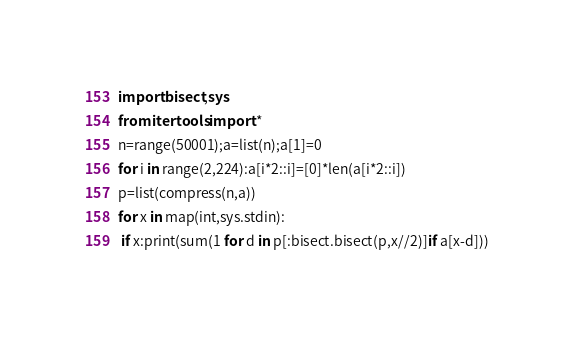<code> <loc_0><loc_0><loc_500><loc_500><_Python_>import bisect,sys
from itertools import *
n=range(50001);a=list(n);a[1]=0
for i in range(2,224):a[i*2::i]=[0]*len(a[i*2::i])
p=list(compress(n,a))
for x in map(int,sys.stdin):
 if x:print(sum(1 for d in p[:bisect.bisect(p,x//2)]if a[x-d]))
</code> 